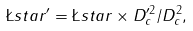Convert formula to latex. <formula><loc_0><loc_0><loc_500><loc_500>\L s t a r ^ { \prime } = \L s t a r \times D _ { c } ^ { \prime 2 } / D _ { c } ^ { 2 } ,</formula> 